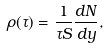Convert formula to latex. <formula><loc_0><loc_0><loc_500><loc_500>\rho ( \tau ) = \frac { 1 } { \tau S } \frac { d N } { d y } ,</formula> 